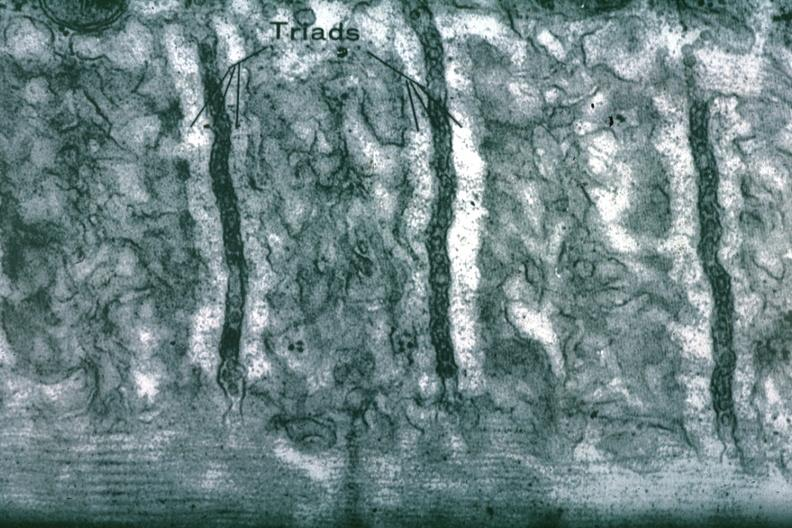where is this area in the body?
Answer the question using a single word or phrase. Heart 